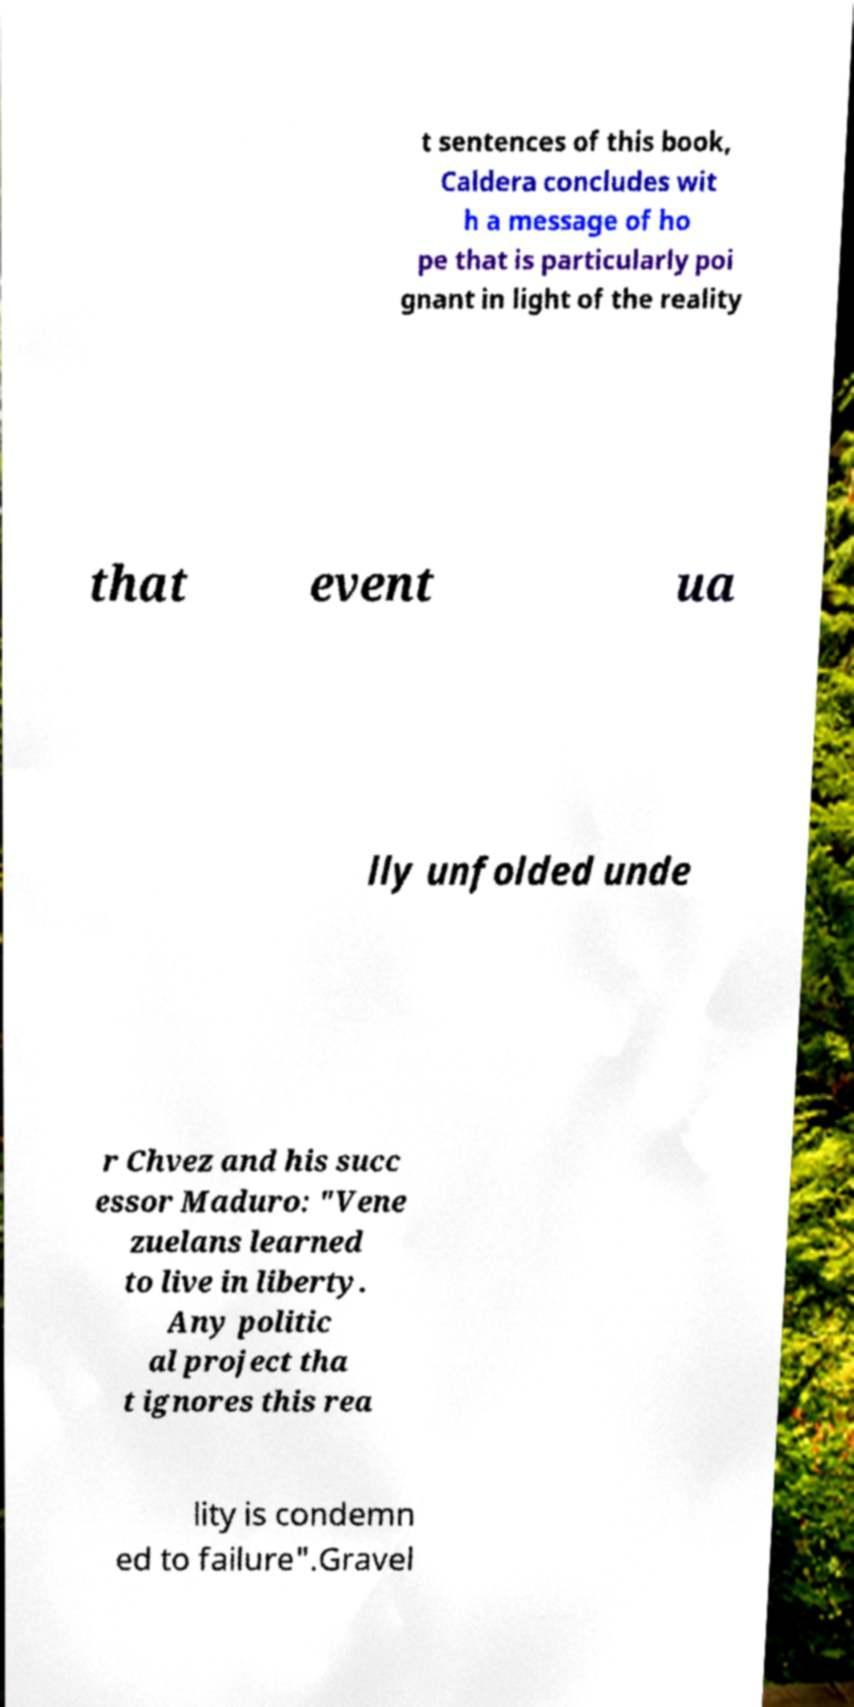Please identify and transcribe the text found in this image. t sentences of this book, Caldera concludes wit h a message of ho pe that is particularly poi gnant in light of the reality that event ua lly unfolded unde r Chvez and his succ essor Maduro: "Vene zuelans learned to live in liberty. Any politic al project tha t ignores this rea lity is condemn ed to failure".Gravel 